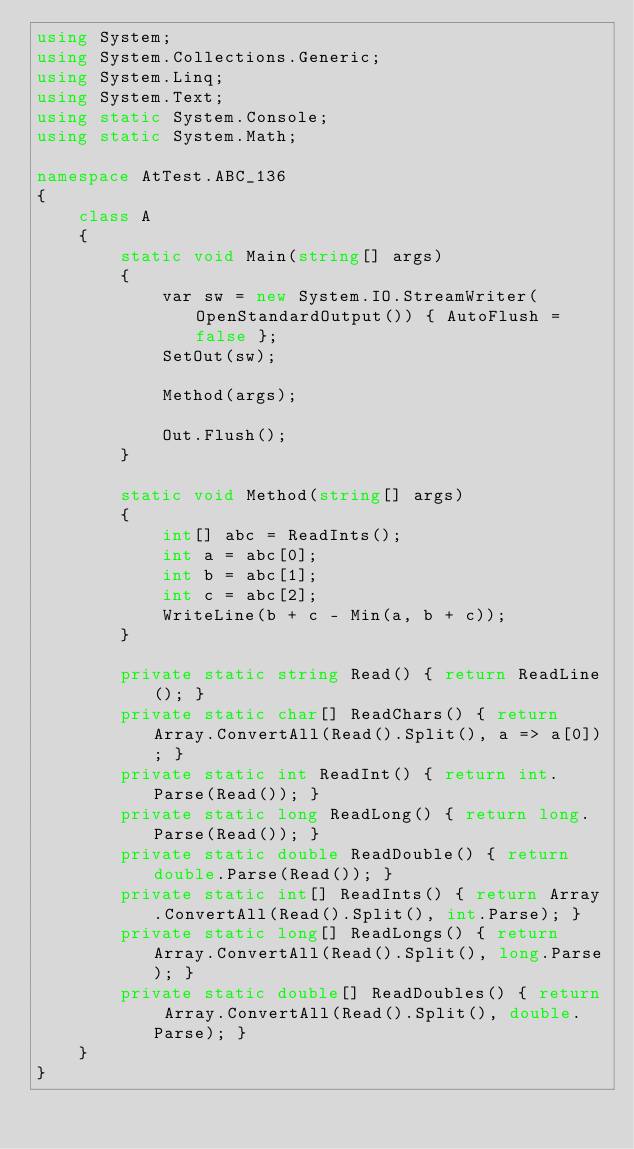<code> <loc_0><loc_0><loc_500><loc_500><_C#_>using System;
using System.Collections.Generic;
using System.Linq;
using System.Text;
using static System.Console;
using static System.Math;

namespace AtTest.ABC_136
{
    class A
    {
        static void Main(string[] args)
        {
            var sw = new System.IO.StreamWriter(OpenStandardOutput()) { AutoFlush = false };
            SetOut(sw);

            Method(args);

            Out.Flush();
        }

        static void Method(string[] args)
        {
            int[] abc = ReadInts();
            int a = abc[0];
            int b = abc[1];
            int c = abc[2];
            WriteLine(b + c - Min(a, b + c));
        }

        private static string Read() { return ReadLine(); }
        private static char[] ReadChars() { return Array.ConvertAll(Read().Split(), a => a[0]); }
        private static int ReadInt() { return int.Parse(Read()); }
        private static long ReadLong() { return long.Parse(Read()); }
        private static double ReadDouble() { return double.Parse(Read()); }
        private static int[] ReadInts() { return Array.ConvertAll(Read().Split(), int.Parse); }
        private static long[] ReadLongs() { return Array.ConvertAll(Read().Split(), long.Parse); }
        private static double[] ReadDoubles() { return Array.ConvertAll(Read().Split(), double.Parse); }
    }
}
</code> 